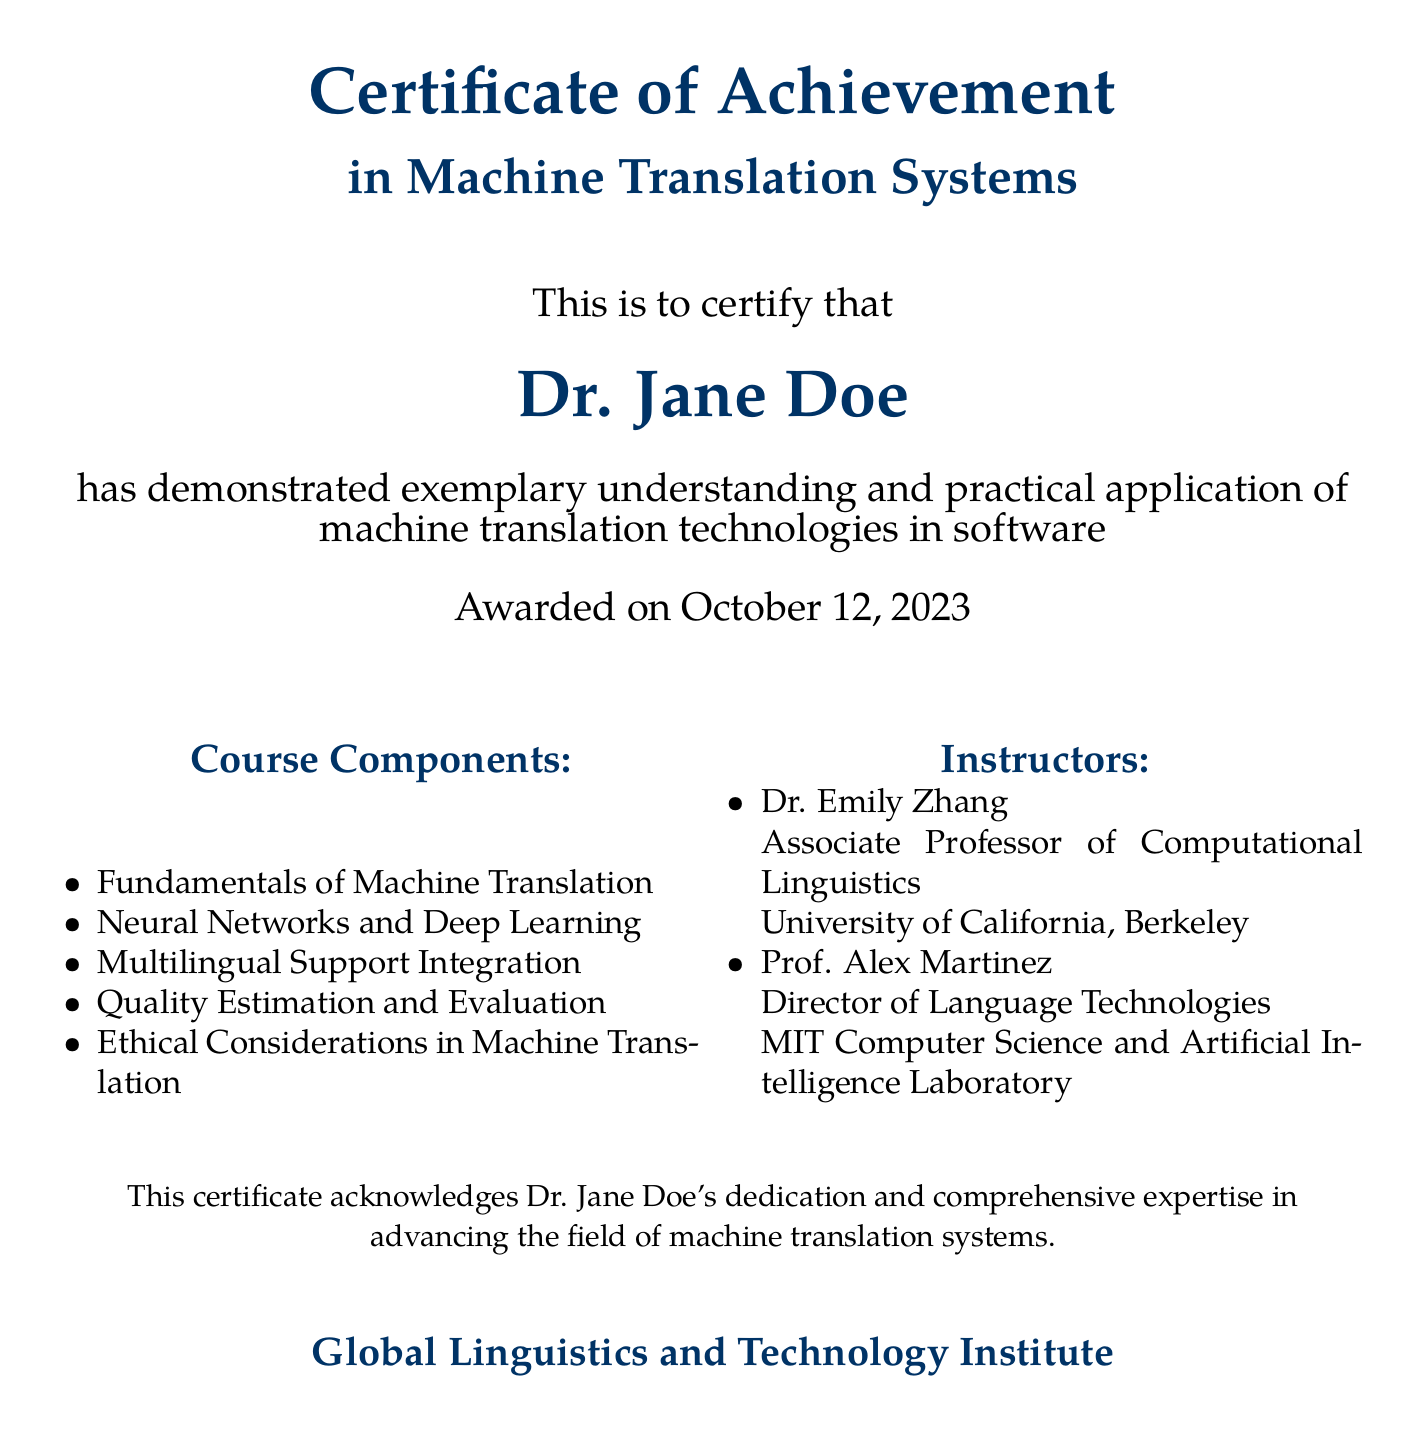What is the title of the certificate? The title of the certificate is displayed at the top of the document, stating the achievement recognized.
Answer: Certificate of Achievement Who is the recipient of the certificate? The recipient of the certificate's name is prominently listed in a large font, indicating who achieved the recognition.
Answer: Dr. Jane Doe When was the certificate awarded? The award date is noted in the document, indicating when the achievement was officially recognized.
Answer: October 12, 2023 What is one course component listed in the document? The document contains a list of course components related to machine translation systems, showcasing what subjects were covered.
Answer: Fundamentals of Machine Translation Who is one of the instructors listed on the certificate? The instructors' names are included, providing information about the educators who taught the relevant course.
Answer: Dr. Emily Zhang What is the name of the issuing institute? The issuing organization is noted at the bottom of the certificate, signifying the authority that confers the achievement.
Answer: Global Linguistics and Technology Institute How many instructors are mentioned in the document? The document specifies the number of instructors included in the certification process, reflecting on the educational environment.
Answer: Two What area of study does this certificate focus on? The focus area of the certificate is highlighted in the title, indicating the specific field of expertise recognized.
Answer: Machine Translation Systems 